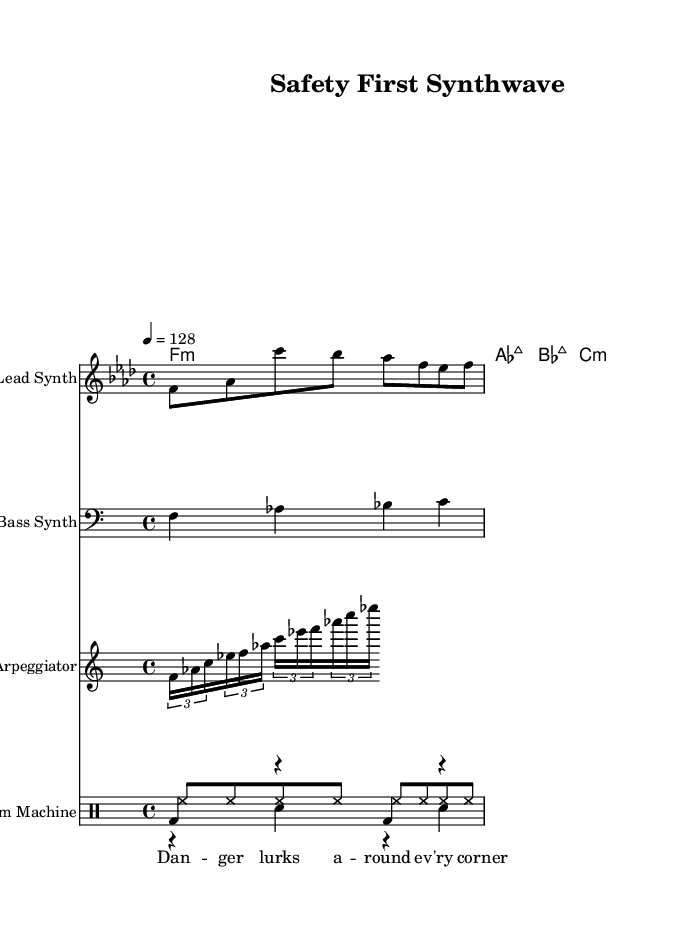What is the key signature of this music? The key signature is indicated by the number of sharps or flats present at the beginning of the staff. In this case, the key signature shows four flats, which corresponds to F minor.
Answer: F minor What is the time signature of this music? The time signature is shown at the beginning of the staff, indicated by the numbers stacked vertically. Here, it shows 4 over 4, meaning four beats per measure and the quarter note receives one beat.
Answer: 4/4 What is the tempo marking for this piece? The tempo marking is typically indicated by a metronome marking at the beginning of the score. This piece has a marking of 128 beats per minute, meaning it should be performed at a moderately fast pace.
Answer: 128 What instruments are featured in this score? The instruments are listed at the beginning of each staff. The score includes Lead Synth, Bass Synth, Arpeggiator, and Drum Machine.
Answer: Lead Synth, Bass Synth, Arpeggiator, Drum Machine How many measures are there in the melody? To determine the number of measures, count the divisions created by vertical lines on the score. The melody section is shown to have four measures, delineated by these bar lines.
Answer: 4 What is the function of the kick pattern in this piece? The kick pattern in electronic music typically serves as the foundation of the rhythm. In this score, it consists of a bass drum sound played on the downbeat to establish the tempo and drive the groove.
Answer: Foundation What cautionary message is conveyed in the lyrics? The lyrics, specifically "Danger lurks around every corner," express a warning or caution about potential hazards or risks. This phrase suggests the importance of being vigilant and aware of one's surroundings.
Answer: Danger 